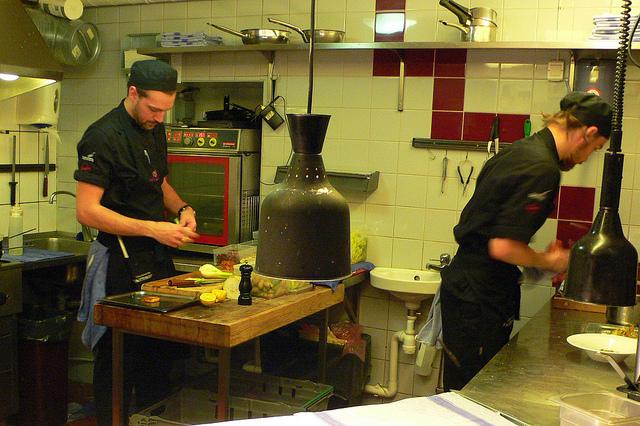Are both men wearing aprons?
Concise answer only. Yes. Are the men cooking in a residential or commercial kitchen?
Answer briefly. Commercial. Do you think the temperature is very cool in this room?
Quick response, please. No. 